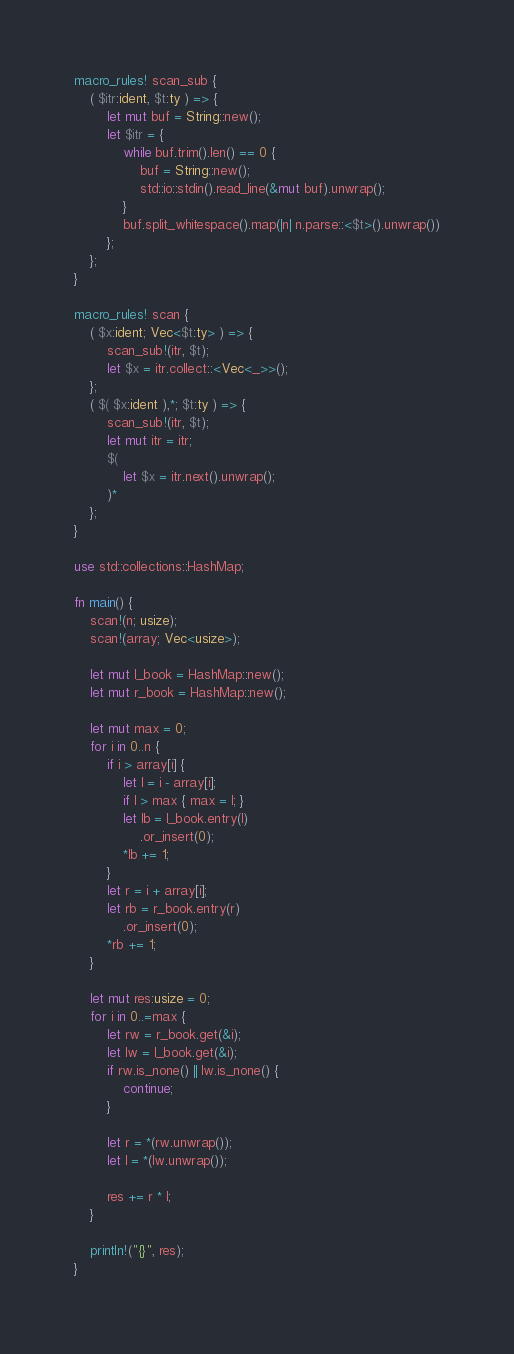<code> <loc_0><loc_0><loc_500><loc_500><_Rust_>macro_rules! scan_sub {
    ( $itr:ident, $t:ty ) => {
        let mut buf = String::new();
        let $itr = {
            while buf.trim().len() == 0 {
                buf = String::new();
                std::io::stdin().read_line(&mut buf).unwrap();
            }
            buf.split_whitespace().map(|n| n.parse::<$t>().unwrap())
        };
    };
}

macro_rules! scan {
    ( $x:ident; Vec<$t:ty> ) => {
        scan_sub!(itr, $t);
        let $x = itr.collect::<Vec<_>>();
    };
    ( $( $x:ident ),*; $t:ty ) => {
        scan_sub!(itr, $t);
        let mut itr = itr;
        $(
            let $x = itr.next().unwrap();
        )*
    };
}

use std::collections::HashMap;

fn main() {
    scan!(n; usize);
    scan!(array; Vec<usize>);

    let mut l_book = HashMap::new();
    let mut r_book = HashMap::new();

    let mut max = 0;
    for i in 0..n {
        if i > array[i] {
            let l = i - array[i];
            if l > max { max = l; }
            let lb = l_book.entry(l)
                .or_insert(0);
            *lb += 1;
        }
        let r = i + array[i];
        let rb = r_book.entry(r)
            .or_insert(0);
        *rb += 1;
    }

    let mut res:usize = 0;
    for i in 0..=max {
        let rw = r_book.get(&i);
        let lw = l_book.get(&i);
        if rw.is_none() || lw.is_none() {
            continue;
        }

        let r = *(rw.unwrap());
        let l = *(lw.unwrap());

        res += r * l;
    }

    println!("{}", res);
}
</code> 